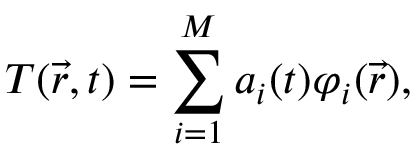<formula> <loc_0><loc_0><loc_500><loc_500>T ( \vec { r } , t ) = \sum _ { i = 1 } ^ { M } a _ { i } ( t ) \varphi _ { i } ( \vec { r } ) ,</formula> 